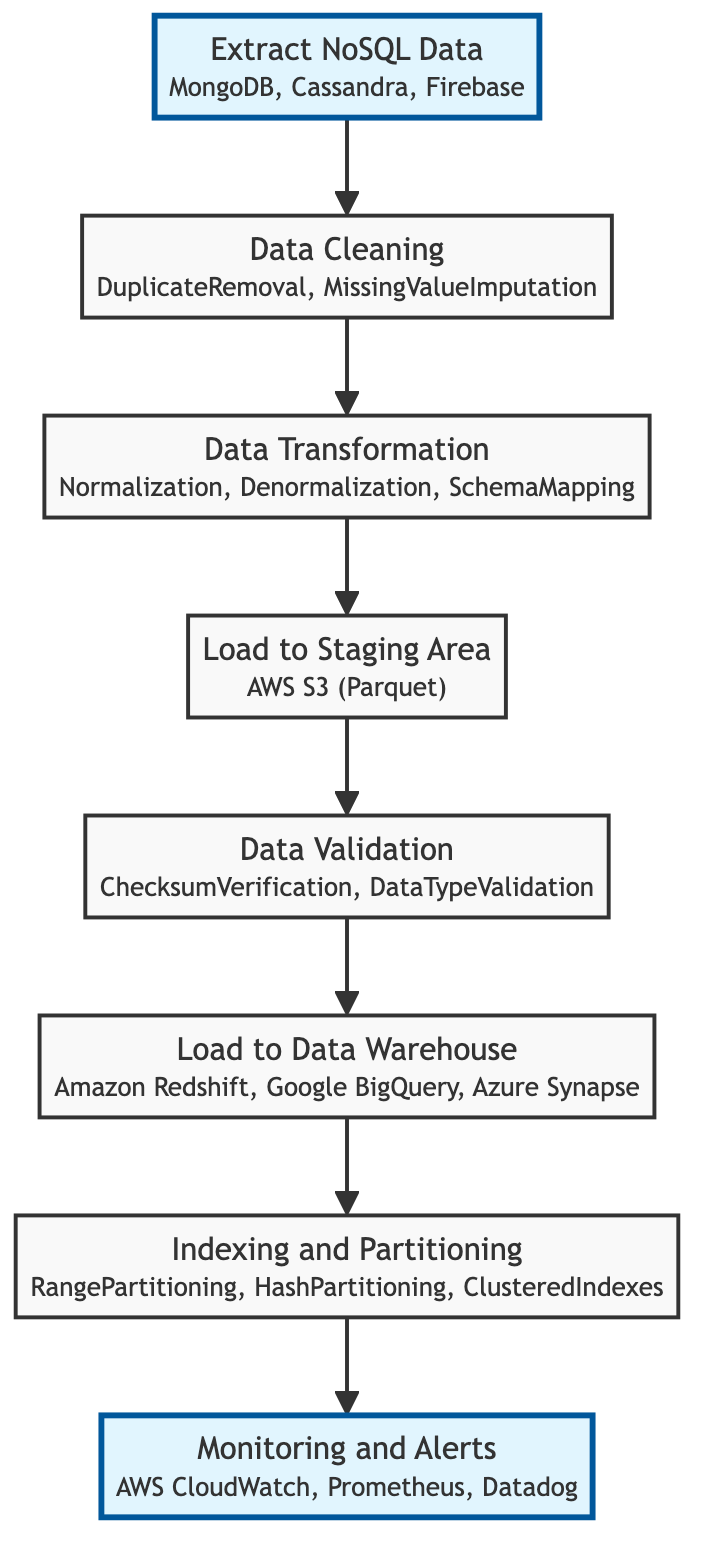What is the first step in the data extraction pipeline? The first step in the data extraction pipeline is represented by the "Extract NoSQL Data" node at the bottom of the flowchart.
Answer: Extract NoSQL Data How many data sources are listed for the NoSQL database extraction? In the "Extract NoSQL Data" step, three data sources are mentioned: MongoDB, Cassandra, and Firebase.
Answer: Three Which step involves validating data integrity? The step that focuses on validating data integrity is "Data Validation," which follows the "Load to Staging Area" step in the flowchart.
Answer: Data Validation What format is the data loaded into the Staging Area? The "Load to Staging Area" step indicates the data is loaded into AWS S3 in the Parquet format.
Answer: Parquet Which two steps are directly connected to the "Indexing and Partitioning" step? The "Load to Data Warehouse" and "Monitoring and Alerts" steps are directly connected to "Indexing and Partitioning," indicating the flow of operations before and after this step.
Answer: Load to Data Warehouse and Monitoring and Alerts What methods are used in the Data Cleaning step? The "Data Cleaning" step mentions two methods used: DuplicateRemoval and MissingValueImputation to clean the data.
Answer: DuplicateRemoval, MissingValueImputation What destination options are available for loading data into the Data Warehouse? The "Load to Data Warehouse" step specifies three destinations: Amazon Redshift, Google BigQuery, and Azure Synapse.
Answer: Amazon Redshift, Google BigQuery, Azure Synapse How many steps are there in total within the extraction pipeline? By counting each node in the flowchart from bottom to top, there are a total of seven steps in the data extraction pipeline.
Answer: Seven What tools are suggested for monitoring and alerts? The "Monitoring and Alerts" step lists three tools: AWS CloudWatch, Prometheus, and Datadog for setting up monitoring and alerts.
Answer: AWS CloudWatch, Prometheus, Datadog 